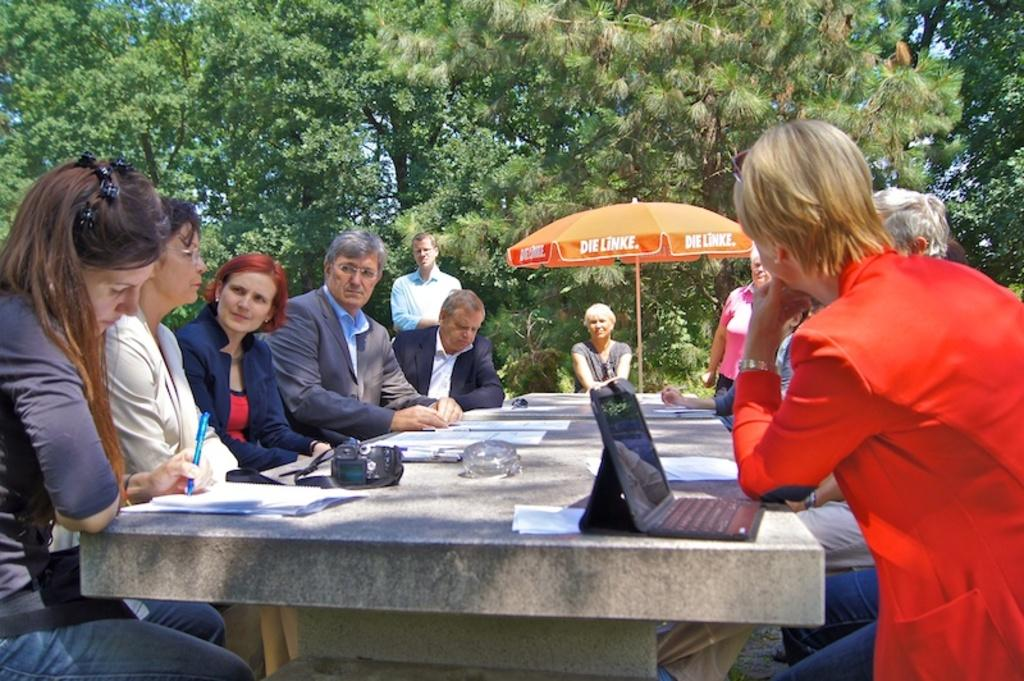How many people are in the image? There is a group of people in the image. What are the people doing in the image? The people are sitting in front of a rock. What objects can be seen on the rock? There is a laptop, papers, and a camera on the rock. What is visible in the background of the image? There is an umbrella and trees in the background of the image. What type of waste can be seen in the image? There is no waste present in the image. Is the group of people driving a tank in the image? There is no tank present in the image, and the group of people is sitting, not driving. 